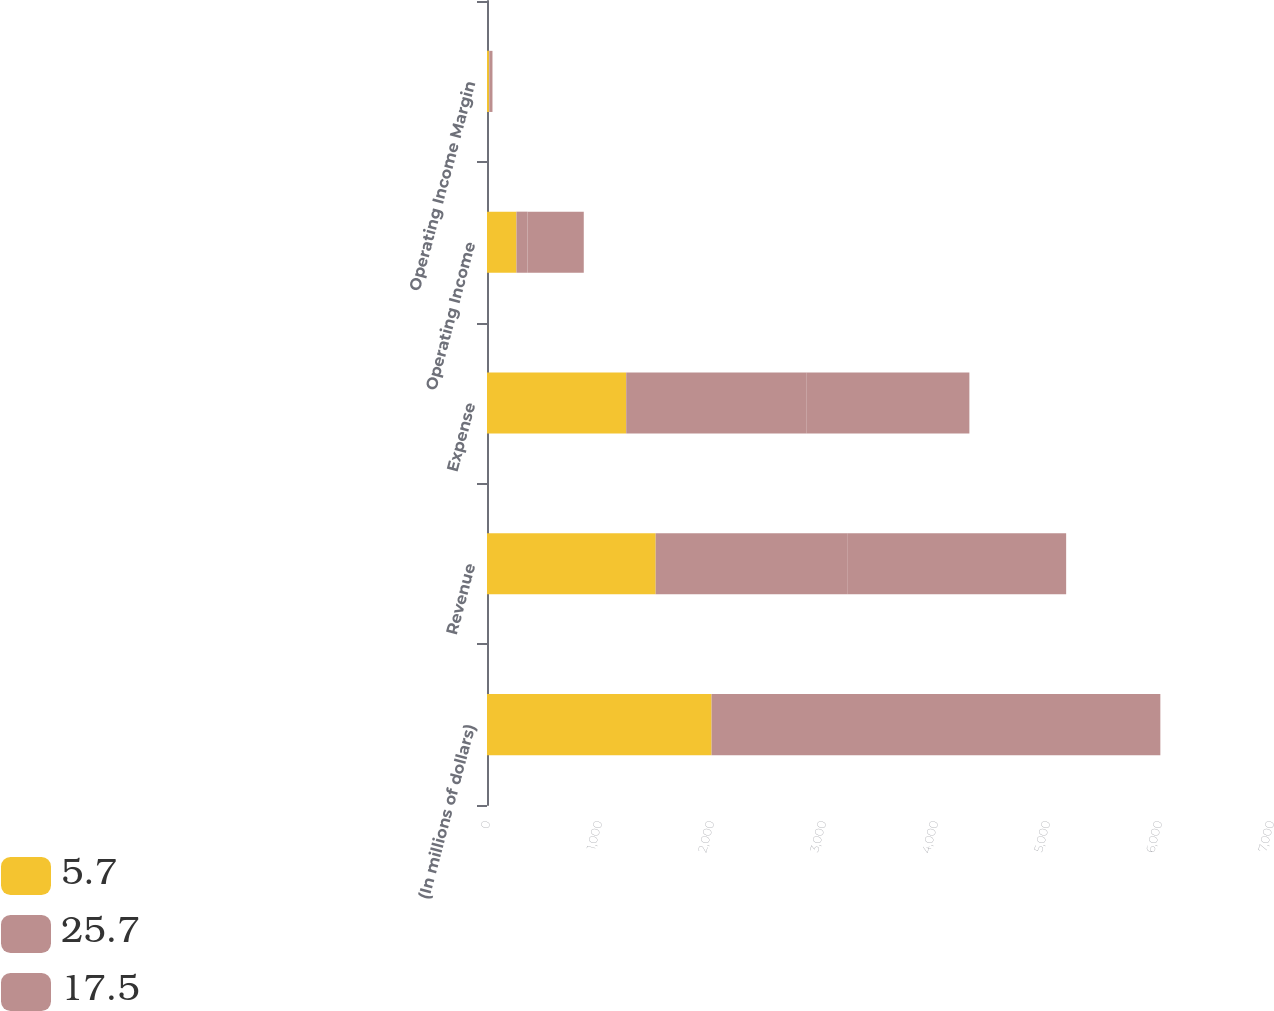<chart> <loc_0><loc_0><loc_500><loc_500><stacked_bar_chart><ecel><fcel>(In millions of dollars)<fcel>Revenue<fcel>Expense<fcel>Operating Income<fcel>Operating Income Margin<nl><fcel>5.7<fcel>2005<fcel>1506<fcel>1243<fcel>263<fcel>17.5<nl><fcel>25.7<fcel>2004<fcel>1710<fcel>1612<fcel>98<fcel>5.7<nl><fcel>17.5<fcel>2003<fcel>1955<fcel>1452<fcel>503<fcel>25.7<nl></chart> 